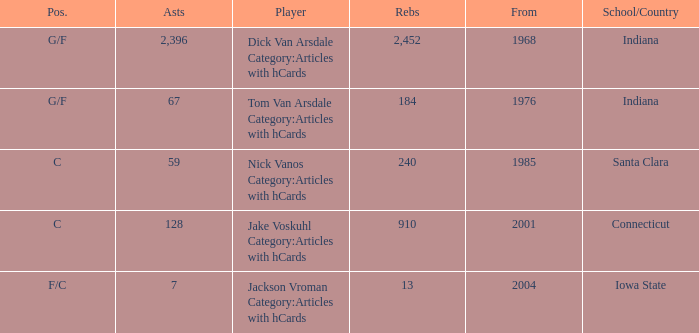What is the highest number of assists for players that are f/c and have under 13 rebounds? None. 